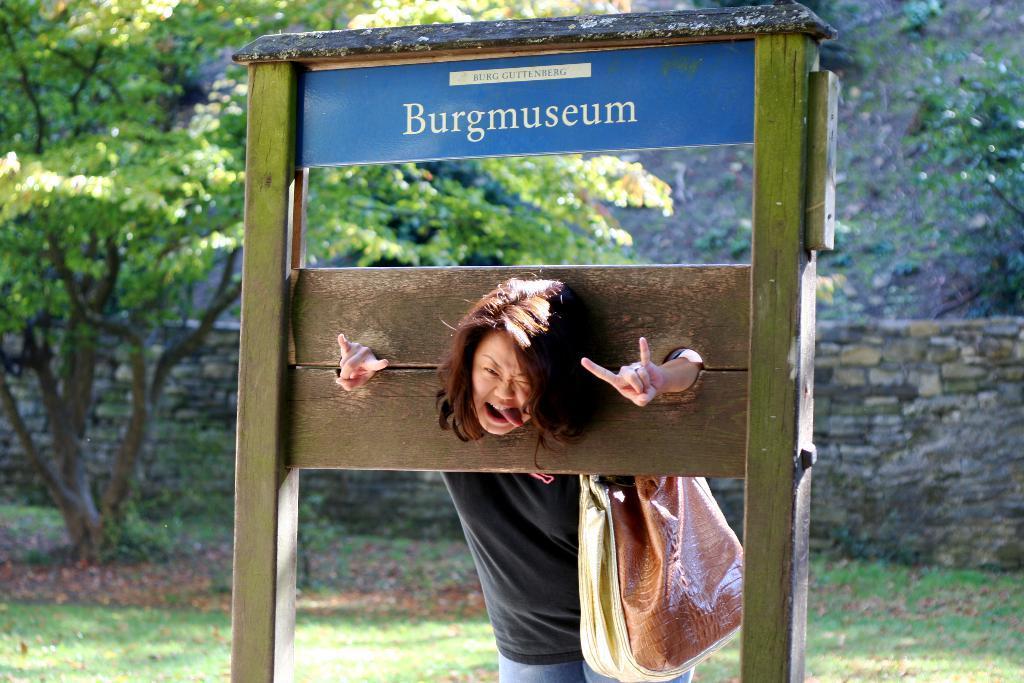Please provide a concise description of this image. In this image there is a woman standing is wearing a black shirt is carrying a bag. At the left side there is a tree. behind there is a wall. At the bottom of image there is a grassy land. 